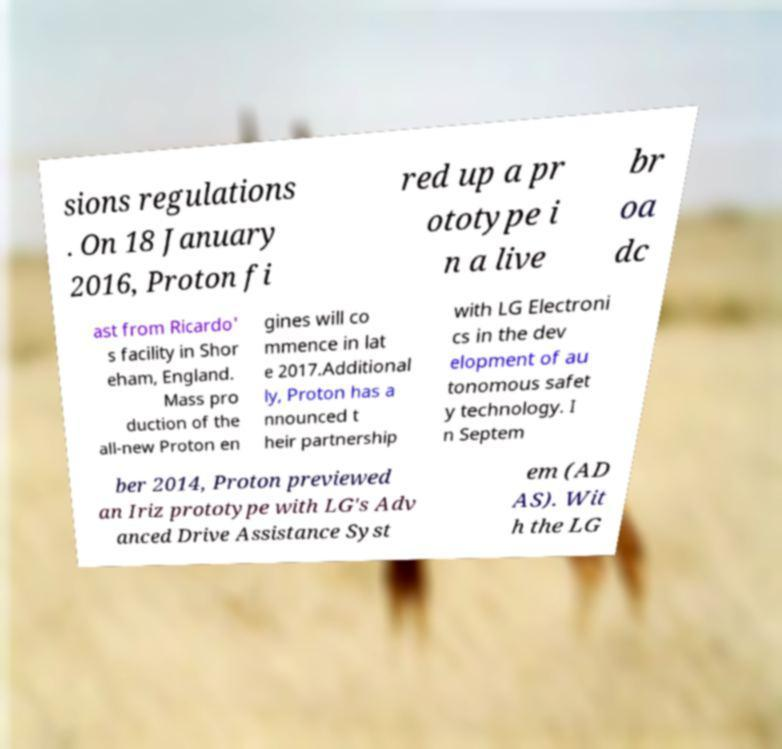Please read and relay the text visible in this image. What does it say? sions regulations . On 18 January 2016, Proton fi red up a pr ototype i n a live br oa dc ast from Ricardo' s facility in Shor eham, England. Mass pro duction of the all-new Proton en gines will co mmence in lat e 2017.Additional ly, Proton has a nnounced t heir partnership with LG Electroni cs in the dev elopment of au tonomous safet y technology. I n Septem ber 2014, Proton previewed an Iriz prototype with LG's Adv anced Drive Assistance Syst em (AD AS). Wit h the LG 